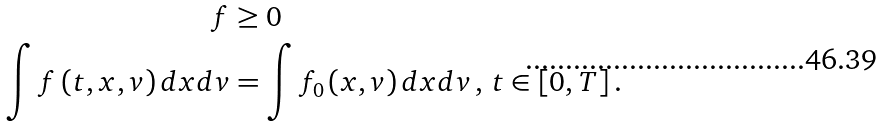Convert formula to latex. <formula><loc_0><loc_0><loc_500><loc_500>f & \geq 0 \, \\ \int f \left ( t , x , v \right ) d x d v & = \int f _ { 0 } \left ( x , v \right ) d x d v \, , \, t \in \left [ 0 , T \right ] .</formula> 